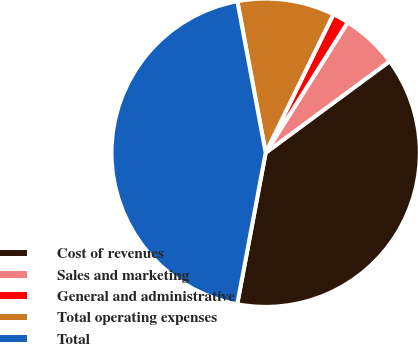Convert chart to OTSL. <chart><loc_0><loc_0><loc_500><loc_500><pie_chart><fcel>Cost of revenues<fcel>Sales and marketing<fcel>General and administrative<fcel>Total operating expenses<fcel>Total<nl><fcel>38.07%<fcel>5.94%<fcel>1.7%<fcel>10.18%<fcel>44.1%<nl></chart> 